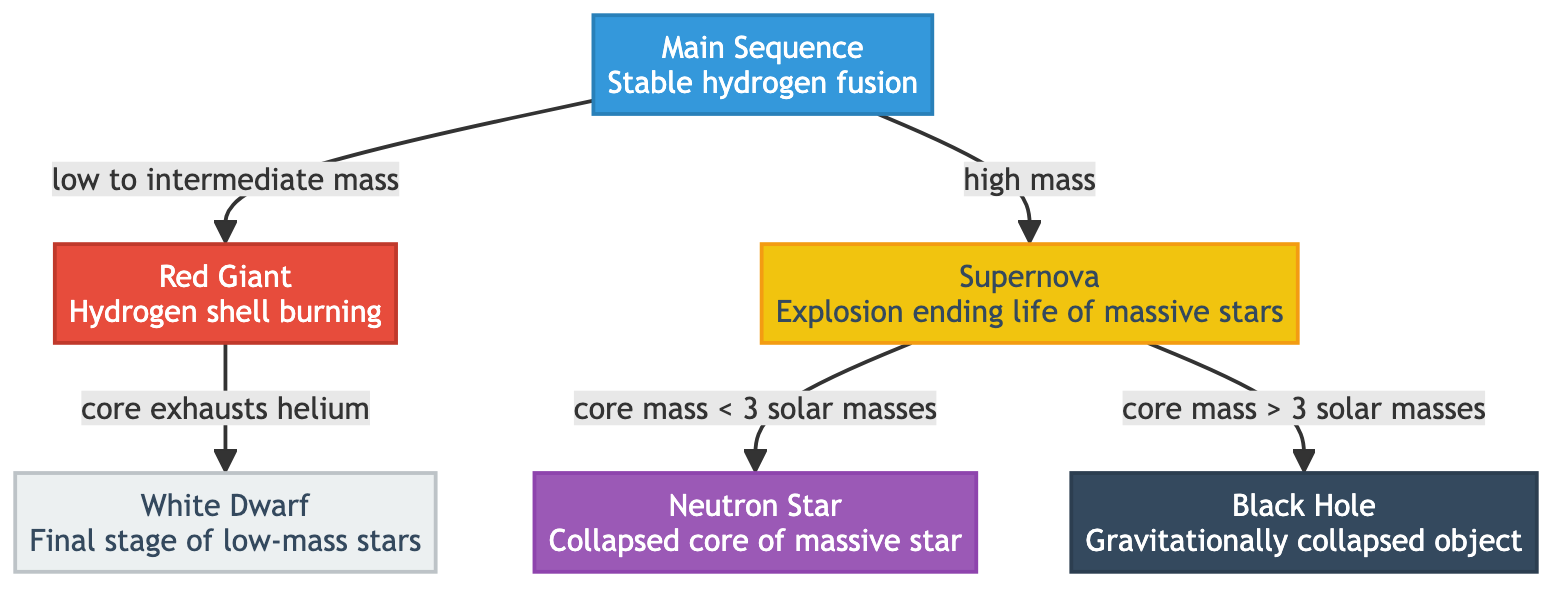What is the first stage of stellar evolution according to the diagram? The diagram indicates that the first stage of stellar evolution is the "Main Sequence" where stable hydrogen fusion occurs. This can be observed as the starting point of the flowchart leading to subsequent stages.
Answer: Main Sequence What life stage follows a Red Giant? Looking at the flow from the Red Giant node, we see it points to the White Dwarf, indicating that a White Dwarf is the subsequent stage after a Red Giant.
Answer: White Dwarf How many primary stages are indicated in the diagram? The diagram contains six distinct stages of stellar evolution: Main Sequence, Red Giant, White Dwarf, Supernova, Neutron Star, and Black Hole. Counting these nodes provides the total.
Answer: Six What is the transition from high mass stars indicated in the diagram? The diagram illustrates that high mass stars transition from the Main Sequence to the Supernova stage, and this is the sole transition for high mass stars depicted in the flowchart.
Answer: Supernova What happens when the core mass of a star is less than 3 solar masses after a supernova? The diagram shows a branching from the Supernova node where if the core mass is less than 3 solar masses, it transitions to a Neutron Star. Hence, this is the resulting life stage for such stars.
Answer: Neutron Star What is the final stage of low-mass stars according to the diagram? From the diagram, it explicitly states that the final stage for low-mass stars is the White Dwarf, which follows the Red Giant stage.
Answer: White Dwarf What stage leads to the formation of a Black Hole? Following the Supernova node, the diagram indicates that if the core mass is greater than 3 solar masses, it evolves into a Black Hole, highlighting this specific pathway at this decision point.
Answer: Black Hole How is hydrogen fusion characterized in the Main Sequence phase? The diagram labels the Main Sequence stage as "Stable hydrogen fusion," clearly defining the nature of this phase. This description is directly associated with the Main Sequence node.
Answer: Stable hydrogen fusion 